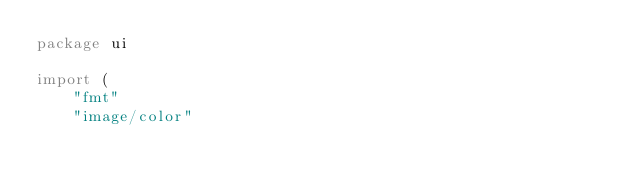Convert code to text. <code><loc_0><loc_0><loc_500><loc_500><_Go_>package ui

import (
	"fmt"
	"image/color"
</code> 